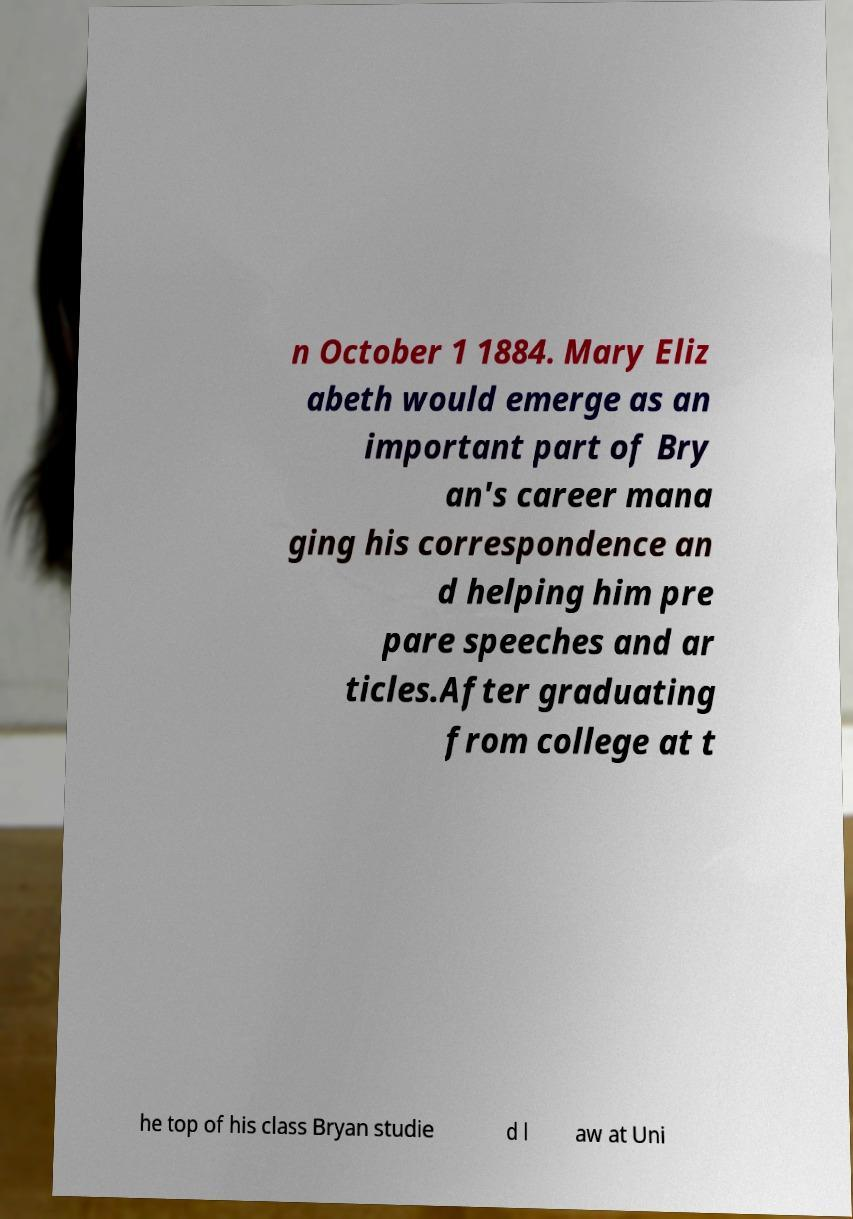Please read and relay the text visible in this image. What does it say? n October 1 1884. Mary Eliz abeth would emerge as an important part of Bry an's career mana ging his correspondence an d helping him pre pare speeches and ar ticles.After graduating from college at t he top of his class Bryan studie d l aw at Uni 